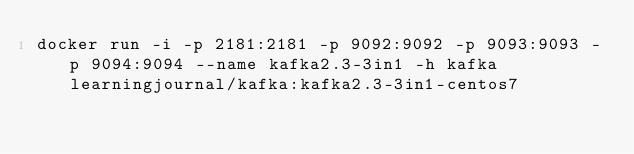<code> <loc_0><loc_0><loc_500><loc_500><_Bash_>docker run -i -p 2181:2181 -p 9092:9092 -p 9093:9093 -p 9094:9094 --name kafka2.3-3in1 -h kafka learningjournal/kafka:kafka2.3-3in1-centos7
</code> 